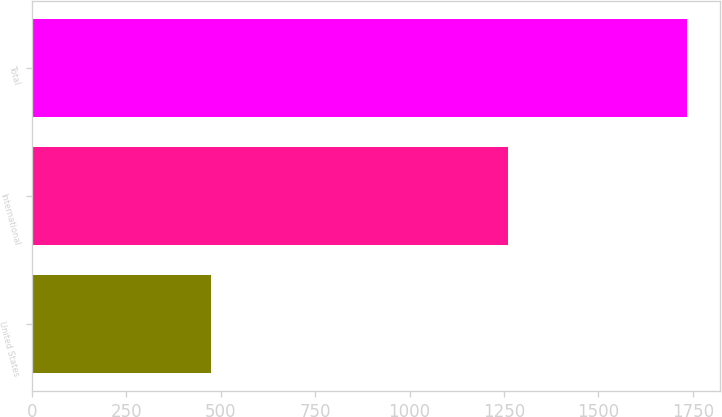Convert chart. <chart><loc_0><loc_0><loc_500><loc_500><bar_chart><fcel>United States<fcel>International<fcel>Total<nl><fcel>475<fcel>1260<fcel>1735<nl></chart> 